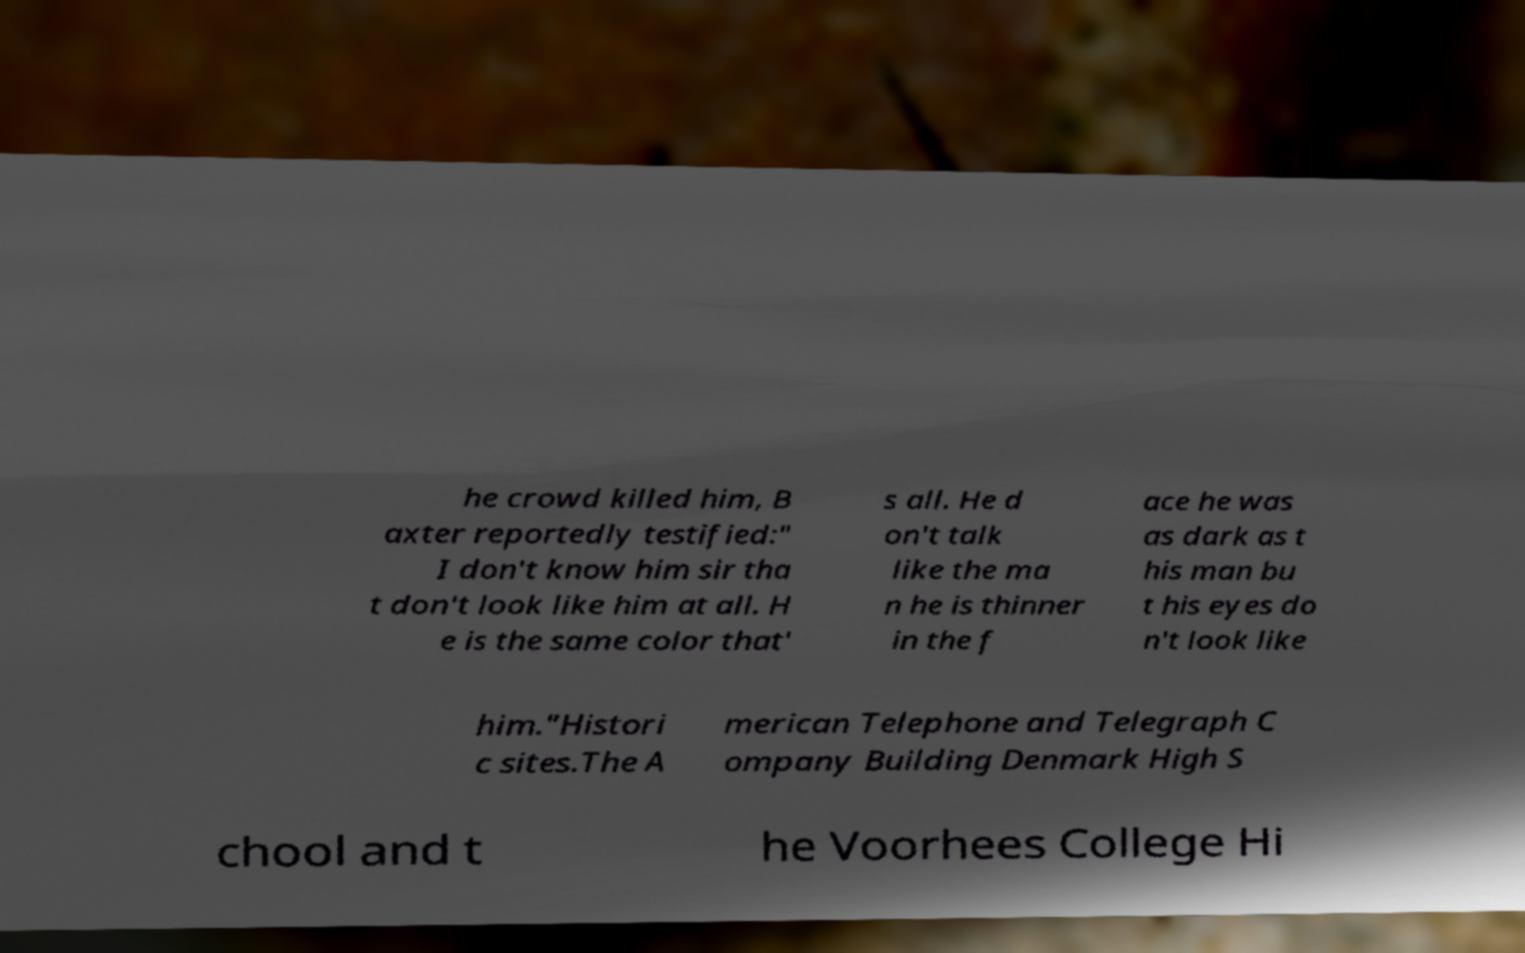Can you accurately transcribe the text from the provided image for me? he crowd killed him, B axter reportedly testified:" I don't know him sir tha t don't look like him at all. H e is the same color that' s all. He d on't talk like the ma n he is thinner in the f ace he was as dark as t his man bu t his eyes do n't look like him."Histori c sites.The A merican Telephone and Telegraph C ompany Building Denmark High S chool and t he Voorhees College Hi 